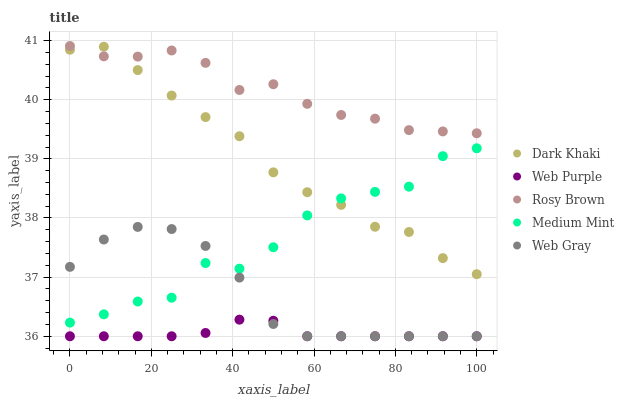Does Web Purple have the minimum area under the curve?
Answer yes or no. Yes. Does Rosy Brown have the maximum area under the curve?
Answer yes or no. Yes. Does Medium Mint have the minimum area under the curve?
Answer yes or no. No. Does Medium Mint have the maximum area under the curve?
Answer yes or no. No. Is Web Purple the smoothest?
Answer yes or no. Yes. Is Medium Mint the roughest?
Answer yes or no. Yes. Is Medium Mint the smoothest?
Answer yes or no. No. Is Web Purple the roughest?
Answer yes or no. No. Does Web Purple have the lowest value?
Answer yes or no. Yes. Does Medium Mint have the lowest value?
Answer yes or no. No. Does Rosy Brown have the highest value?
Answer yes or no. Yes. Does Medium Mint have the highest value?
Answer yes or no. No. Is Web Gray less than Dark Khaki?
Answer yes or no. Yes. Is Medium Mint greater than Web Purple?
Answer yes or no. Yes. Does Medium Mint intersect Dark Khaki?
Answer yes or no. Yes. Is Medium Mint less than Dark Khaki?
Answer yes or no. No. Is Medium Mint greater than Dark Khaki?
Answer yes or no. No. Does Web Gray intersect Dark Khaki?
Answer yes or no. No. 